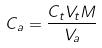Convert formula to latex. <formula><loc_0><loc_0><loc_500><loc_500>C _ { a } = \frac { C _ { t } V _ { t } M } { V _ { a } }</formula> 